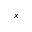Convert formula to latex. <formula><loc_0><loc_0><loc_500><loc_500>x</formula> 